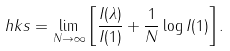Convert formula to latex. <formula><loc_0><loc_0><loc_500><loc_500>\ h k s = \lim _ { N \to \infty } \left [ \frac { I ( \lambda ) } { I ( 1 ) } + \frac { 1 } { N } \log I ( 1 ) \right ] .</formula> 